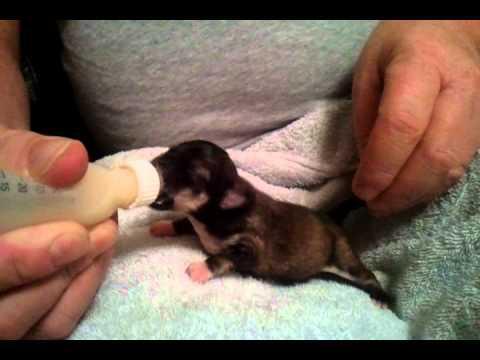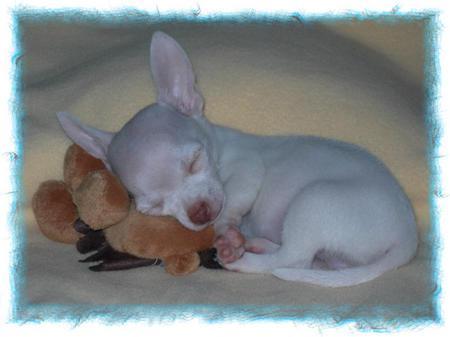The first image is the image on the left, the second image is the image on the right. Assess this claim about the two images: "At least one animal is drinking milk.". Correct or not? Answer yes or no. Yes. The first image is the image on the left, the second image is the image on the right. For the images displayed, is the sentence "There are two chihuahua puppies." factually correct? Answer yes or no. Yes. 